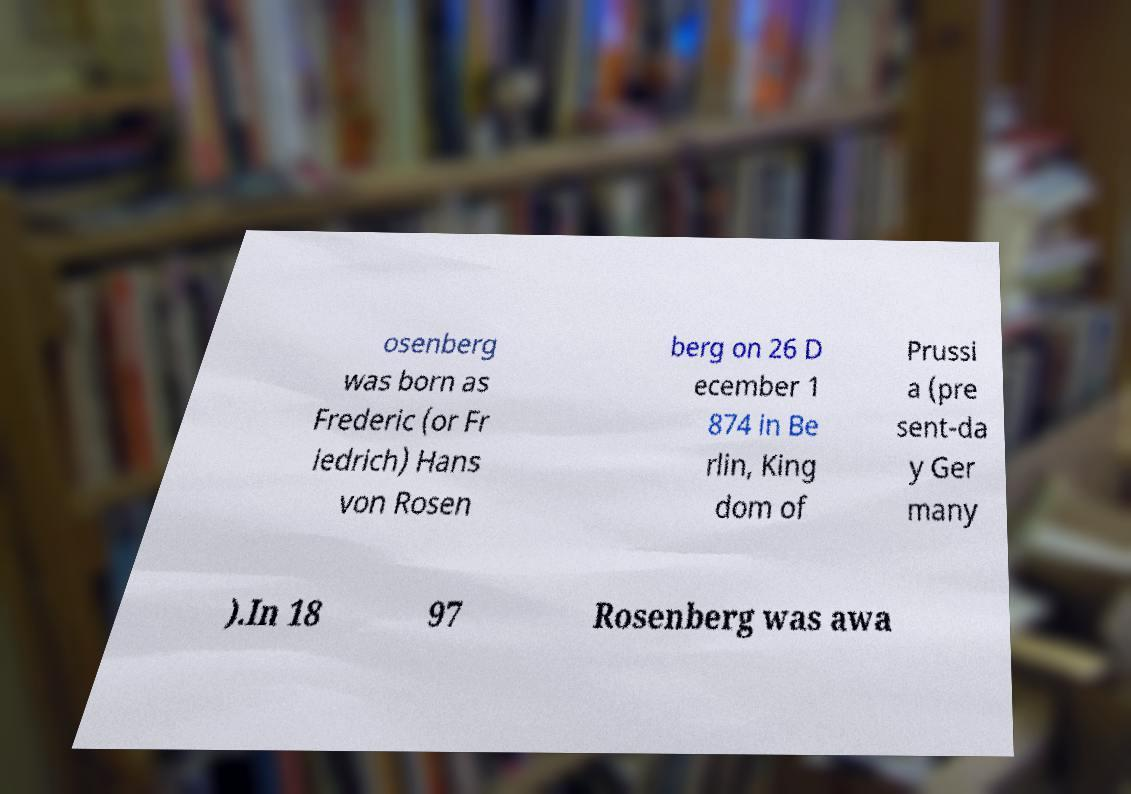Please read and relay the text visible in this image. What does it say? osenberg was born as Frederic (or Fr iedrich) Hans von Rosen berg on 26 D ecember 1 874 in Be rlin, King dom of Prussi a (pre sent-da y Ger many ).In 18 97 Rosenberg was awa 